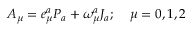<formula> <loc_0><loc_0><loc_500><loc_500>A _ { \mu } = e _ { \mu } ^ { a } P _ { a } + \omega _ { \mu } ^ { a } J _ { a } ; \, \mu = 0 , 1 , 2</formula> 